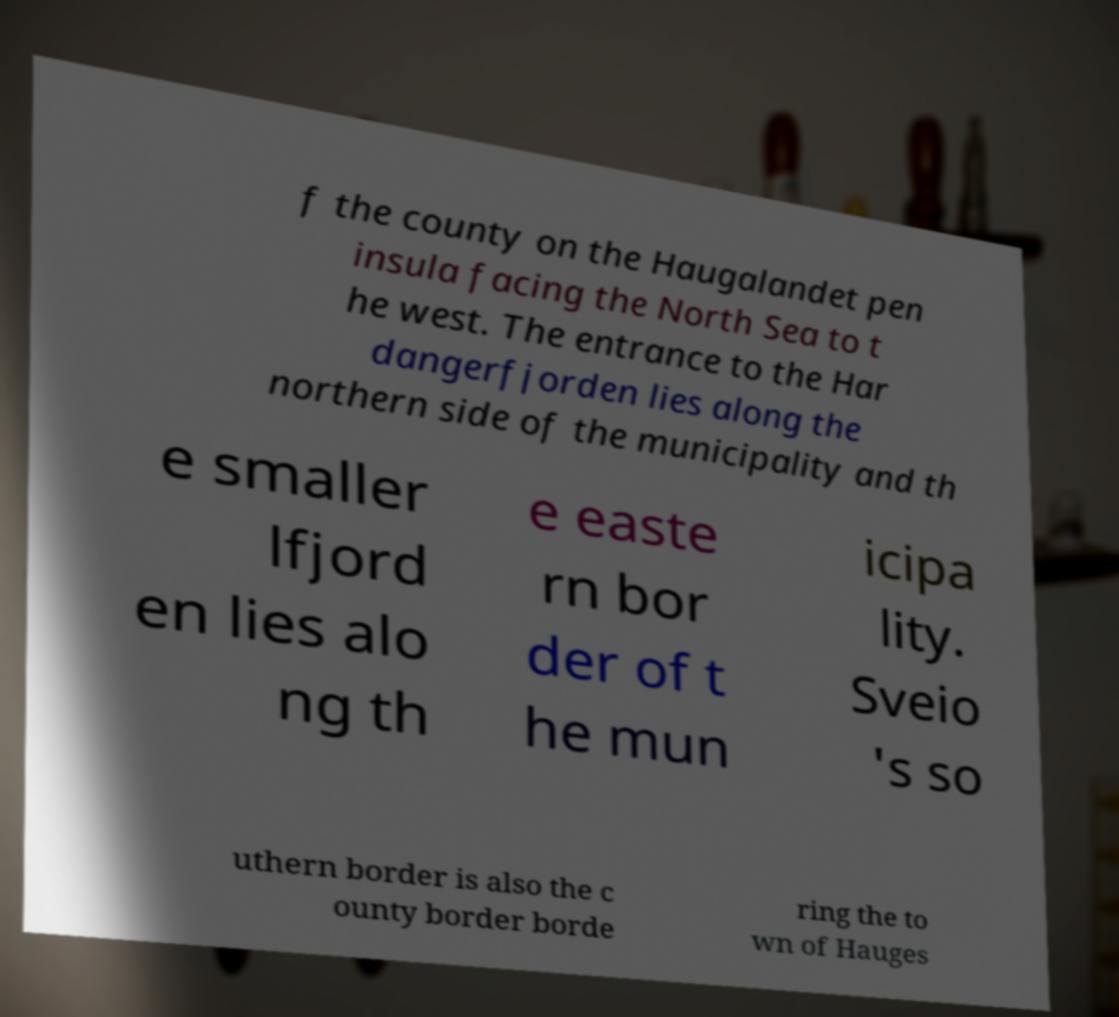What messages or text are displayed in this image? I need them in a readable, typed format. f the county on the Haugalandet pen insula facing the North Sea to t he west. The entrance to the Har dangerfjorden lies along the northern side of the municipality and th e smaller lfjord en lies alo ng th e easte rn bor der of t he mun icipa lity. Sveio 's so uthern border is also the c ounty border borde ring the to wn of Hauges 